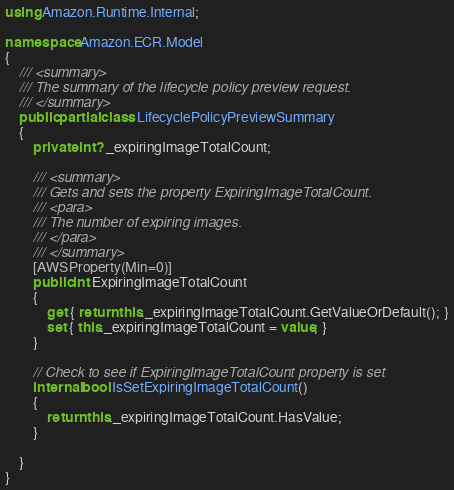<code> <loc_0><loc_0><loc_500><loc_500><_C#_>using Amazon.Runtime.Internal;

namespace Amazon.ECR.Model
{
    /// <summary>
    /// The summary of the lifecycle policy preview request.
    /// </summary>
    public partial class LifecyclePolicyPreviewSummary
    {
        private int? _expiringImageTotalCount;

        /// <summary>
        /// Gets and sets the property ExpiringImageTotalCount. 
        /// <para>
        /// The number of expiring images.
        /// </para>
        /// </summary>
        [AWSProperty(Min=0)]
        public int ExpiringImageTotalCount
        {
            get { return this._expiringImageTotalCount.GetValueOrDefault(); }
            set { this._expiringImageTotalCount = value; }
        }

        // Check to see if ExpiringImageTotalCount property is set
        internal bool IsSetExpiringImageTotalCount()
        {
            return this._expiringImageTotalCount.HasValue; 
        }

    }
}</code> 